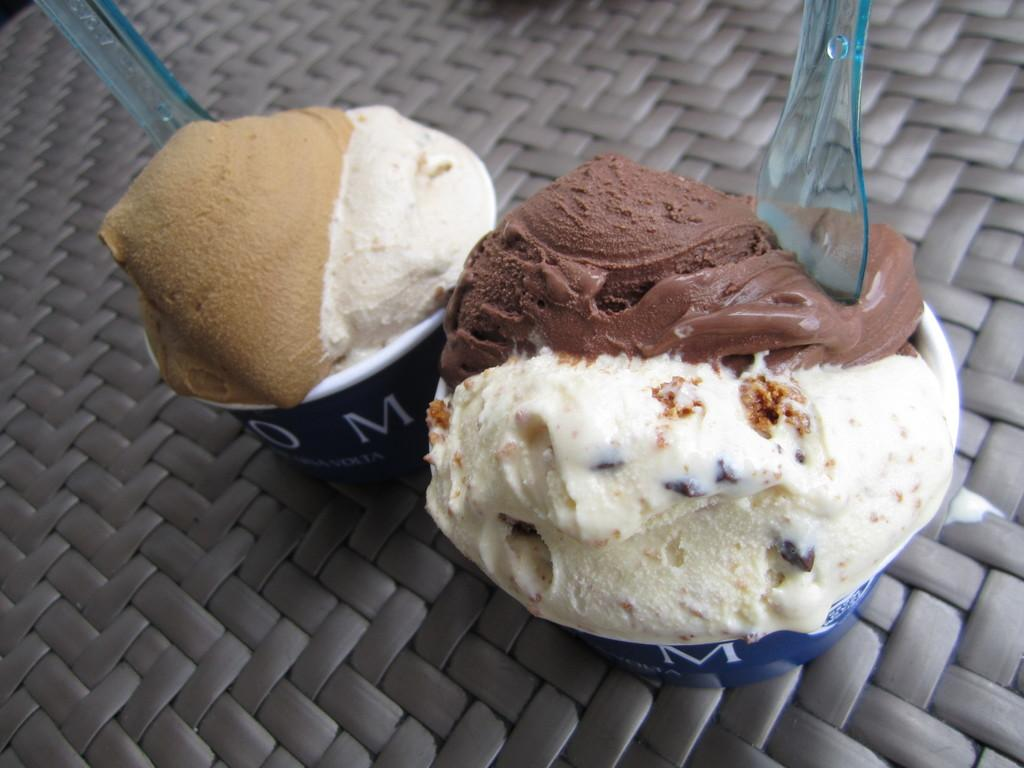What type of dessert is featured in the image? The image features ice cream scoops. What utensils are present in the image? There are spoons in the image. How are the ice cream scoops contained in the image? The ice cream scoops are in cups. What is the cups resting on in the image? The cups are on an object. Is there a beggar asking for ice cream in the image? No, there is no beggar present in the image. What type of root can be seen growing from the ice cream scoops? There are no roots visible in the image; it features ice cream scoops in cups. 